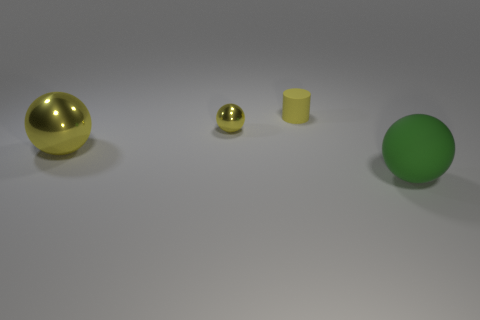What number of big objects are both left of the matte sphere and to the right of the large yellow ball?
Offer a very short reply. 0. How many other things are the same shape as the tiny yellow matte thing?
Provide a short and direct response. 0. Is the number of yellow metal balls that are behind the large yellow metallic object greater than the number of purple cylinders?
Offer a terse response. Yes. What is the color of the object that is right of the yellow rubber cylinder?
Make the answer very short. Green. What is the size of the metallic thing that is the same color as the small shiny ball?
Your answer should be very brief. Large. How many matte objects are either yellow cylinders or purple cylinders?
Keep it short and to the point. 1. Is there a shiny sphere that is to the left of the large ball that is on the left side of the rubber thing that is right of the yellow cylinder?
Your response must be concise. No. How many tiny yellow matte things are behind the large green sphere?
Your answer should be very brief. 1. There is a large ball that is the same color as the small metal ball; what is it made of?
Provide a succinct answer. Metal. How many big things are cylinders or metallic things?
Your response must be concise. 1. 